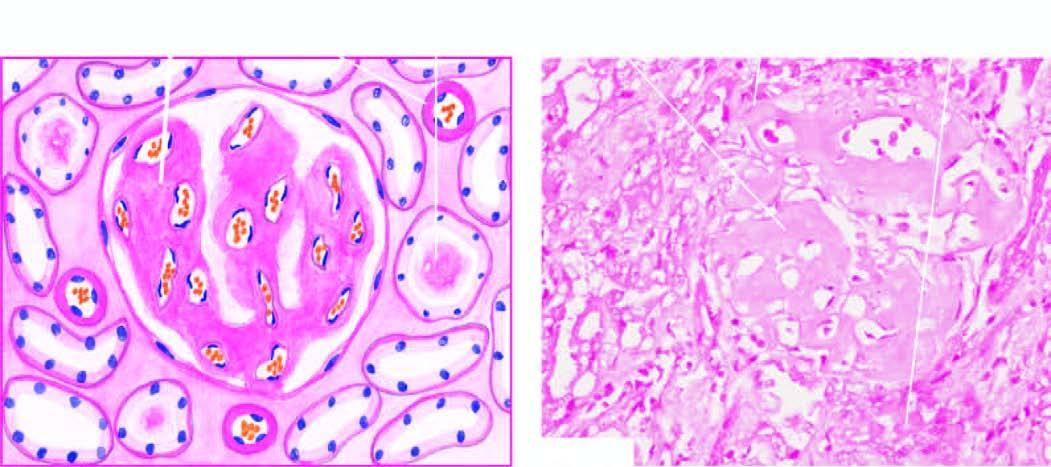does the nucleus cast in the tubular lumina, and in the arterial wall producing luminal narrowing?
Answer the question using a single word or phrase. No 